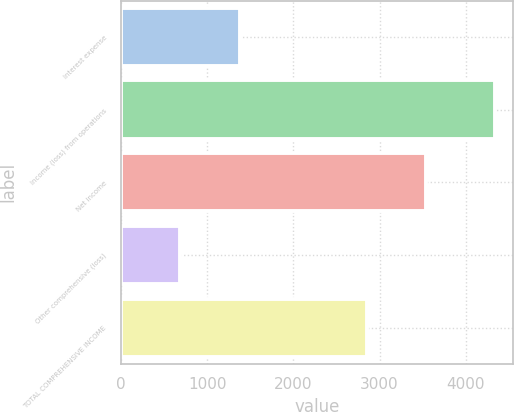Convert chart to OTSL. <chart><loc_0><loc_0><loc_500><loc_500><bar_chart><fcel>Interest expense<fcel>Income (loss) from operations<fcel>Net income<fcel>Other comprehensive (loss)<fcel>TOTAL COMPREHENSIVE INCOME<nl><fcel>1386<fcel>4336<fcel>3538<fcel>684<fcel>2854<nl></chart> 